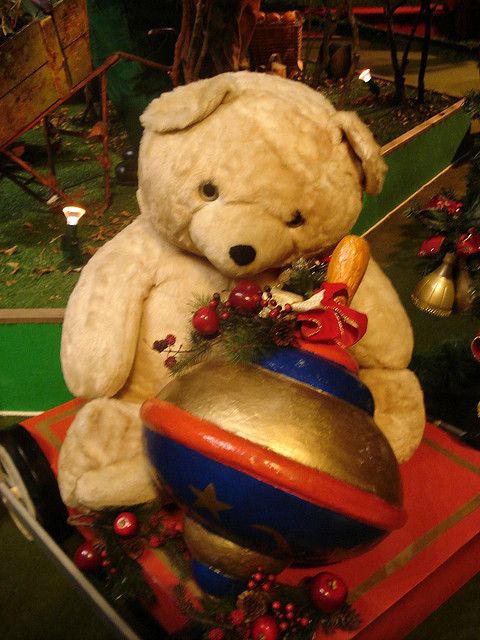Can you describe the setting in which the teddy bear is placed? The teddy bear is part of a festive holiday display, set against a backdrop that resembles an enchanted forest with a warm, twinkling ambiance created by small lights, suggesting a cozy Christmas scene. 